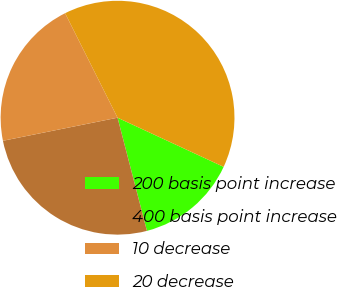Convert chart to OTSL. <chart><loc_0><loc_0><loc_500><loc_500><pie_chart><fcel>200 basis point increase<fcel>400 basis point increase<fcel>10 decrease<fcel>20 decrease<nl><fcel>14.05%<fcel>25.88%<fcel>20.76%<fcel>39.31%<nl></chart> 